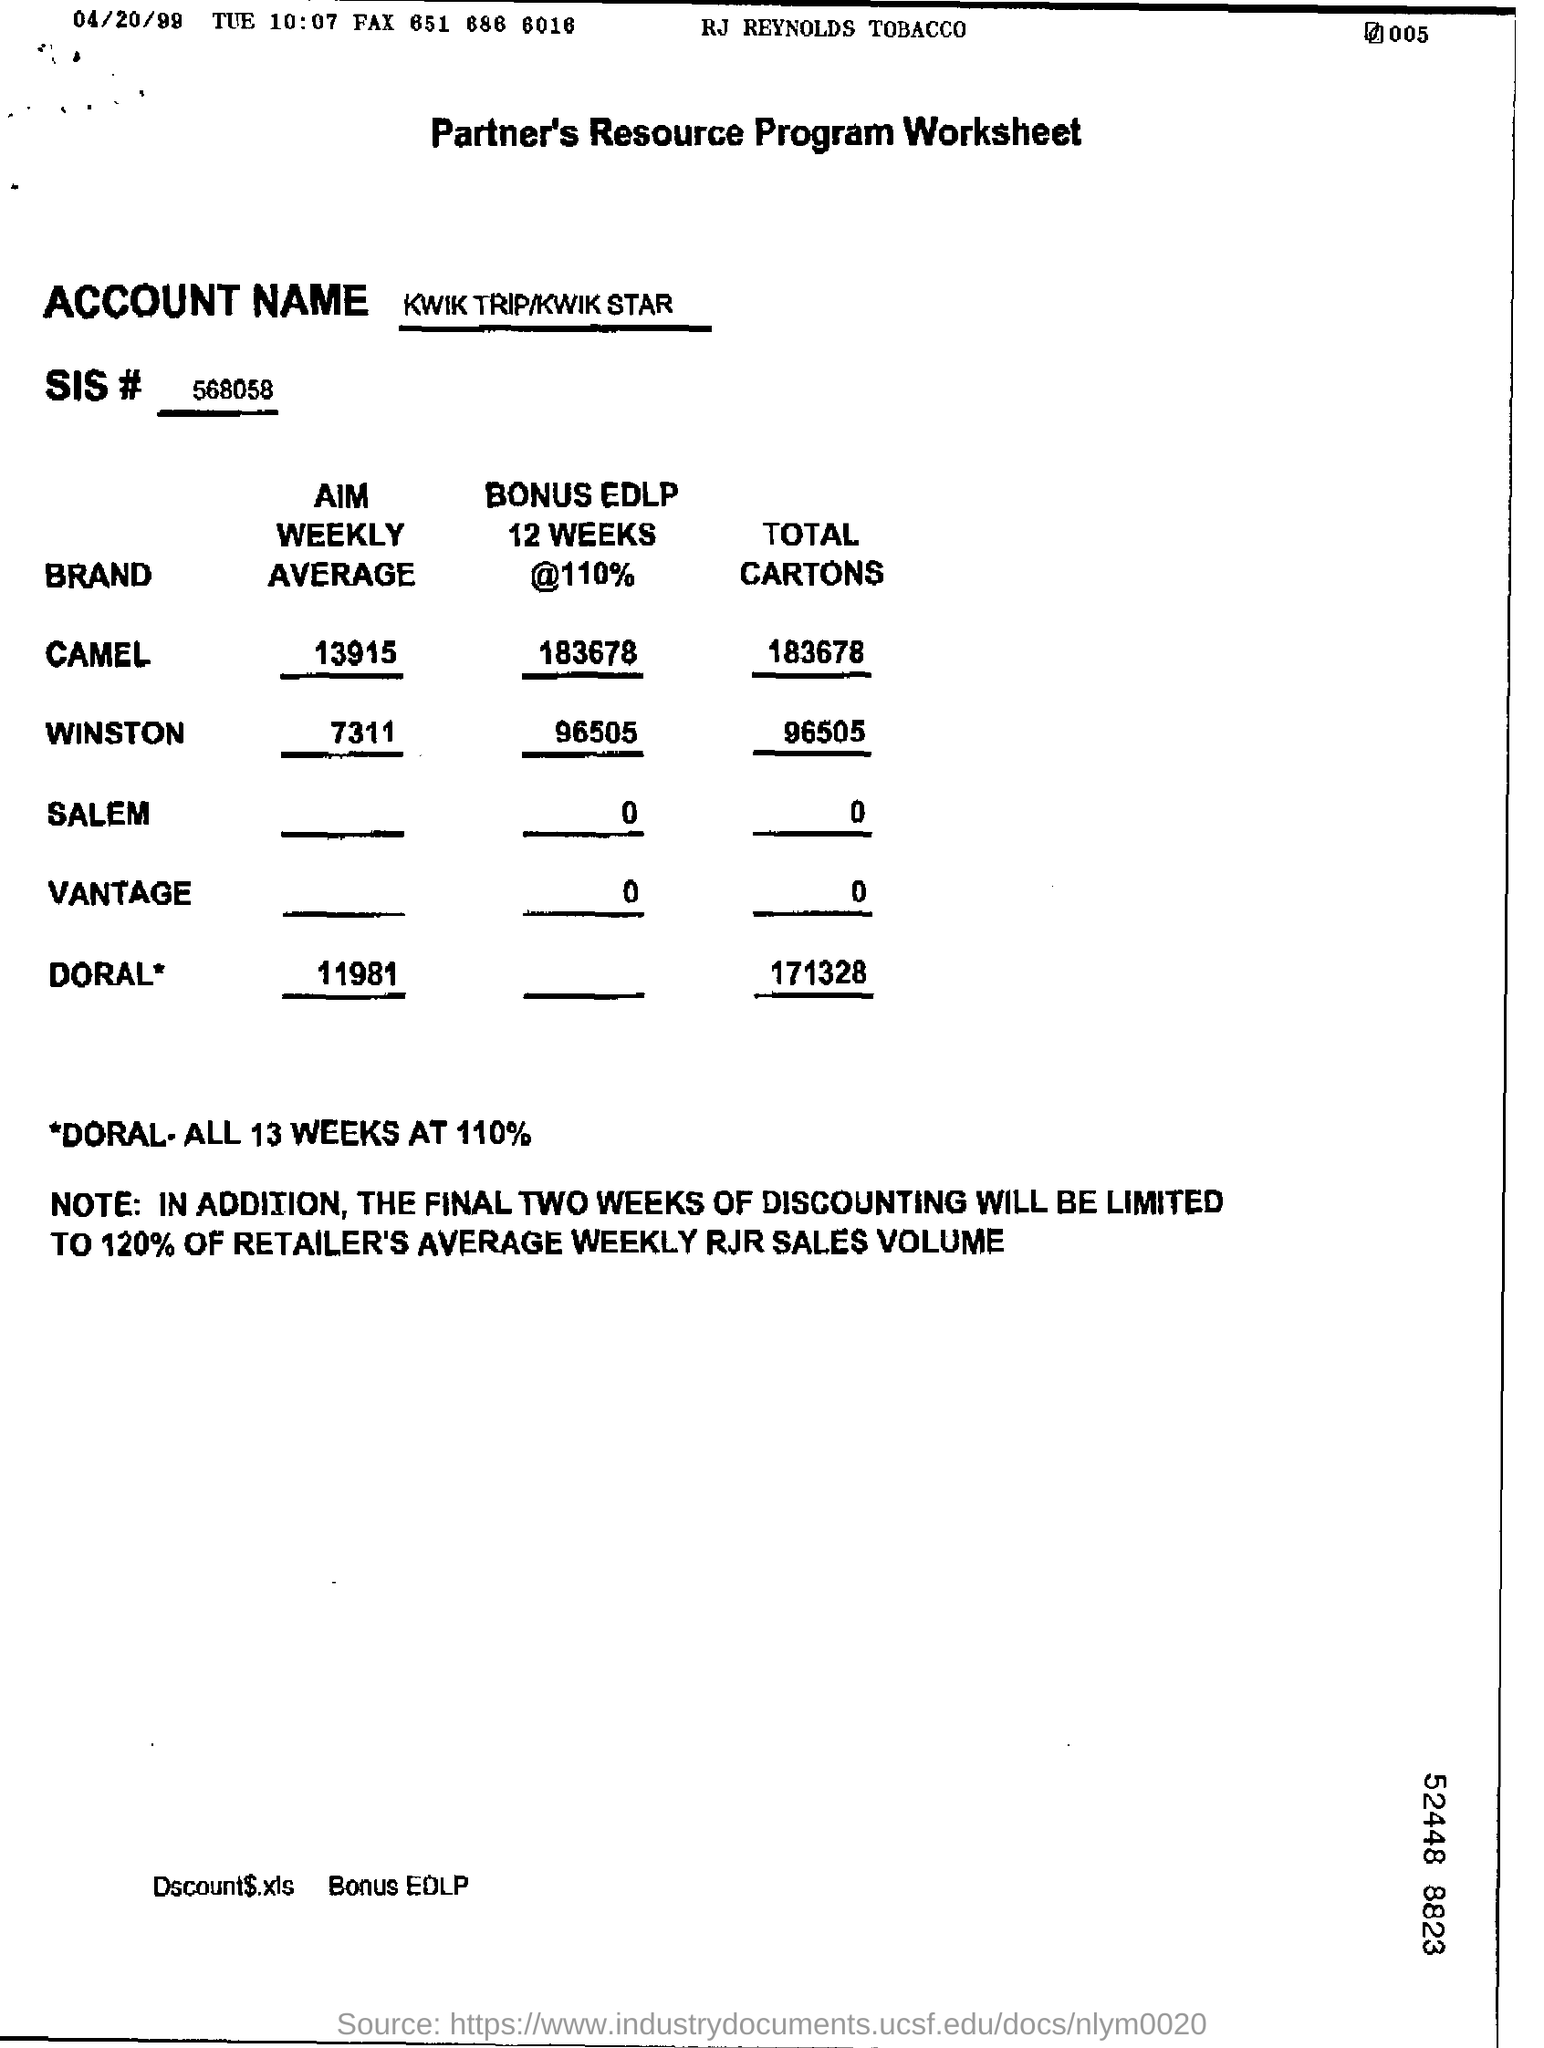Specify some key components in this picture. What is the total number of cartons for VANTAGE? The number can range from 0 to... The weekly average of the brand Winston is 7311. The heading of the document is "The Partner's Resource Program Worksheet. The account name is Kwik Trip/Kwik Star. 